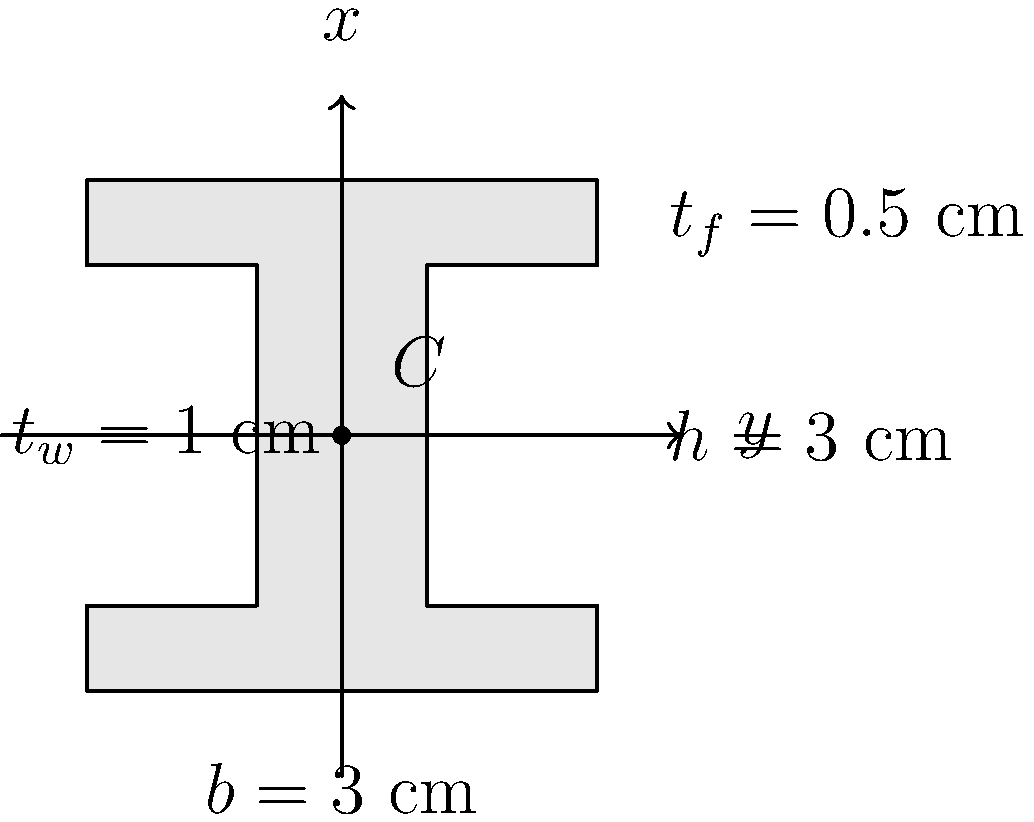As a physicist working with precision instruments, you encounter a problem related to the structural stability of your quantum clock setup. The support structure includes an I-beam with the cross-section shown above. Calculate the moment of inertia $I_x$ of this I-beam cross-section about its centroidal x-axis. Express your answer in cm⁴. To calculate the moment of inertia $I_x$ of the I-beam cross-section about its centroidal x-axis, we'll follow these steps:

1) The I-beam can be divided into three rectangles: two flanges and one web.

2) For a rectangle with base $b$ and height $h$, the moment of inertia about its own centroidal axis parallel to the base is:

   $$I = \frac{1}{12}bh^3$$

3) For the flanges:
   - Width $b_f = 3$ cm
   - Thickness $t_f = 0.5$ cm
   - Distance from centroid to flange centroid $d = (3 - 0.5)/2 = 1.25$ cm

   $$I_{flange} = \frac{1}{12} \cdot 3 \cdot 0.5^3 + 3 \cdot 0.5 \cdot 1.25^2 = 2.3438 \text{ cm}^4$$

4) For the web:
   - Width $t_w = 1$ cm
   - Height $h_w = 3 - 2(0.5) = 2$ cm

   $$I_{web} = \frac{1}{12} \cdot 1 \cdot 2^3 = 0.6667 \text{ cm}^4$$

5) The total moment of inertia is:

   $$I_x = 2I_{flange} + I_{web} = 2(2.3438) + 0.6667 = 5.3543 \text{ cm}^4$$
Answer: $5.3543 \text{ cm}^4$ 